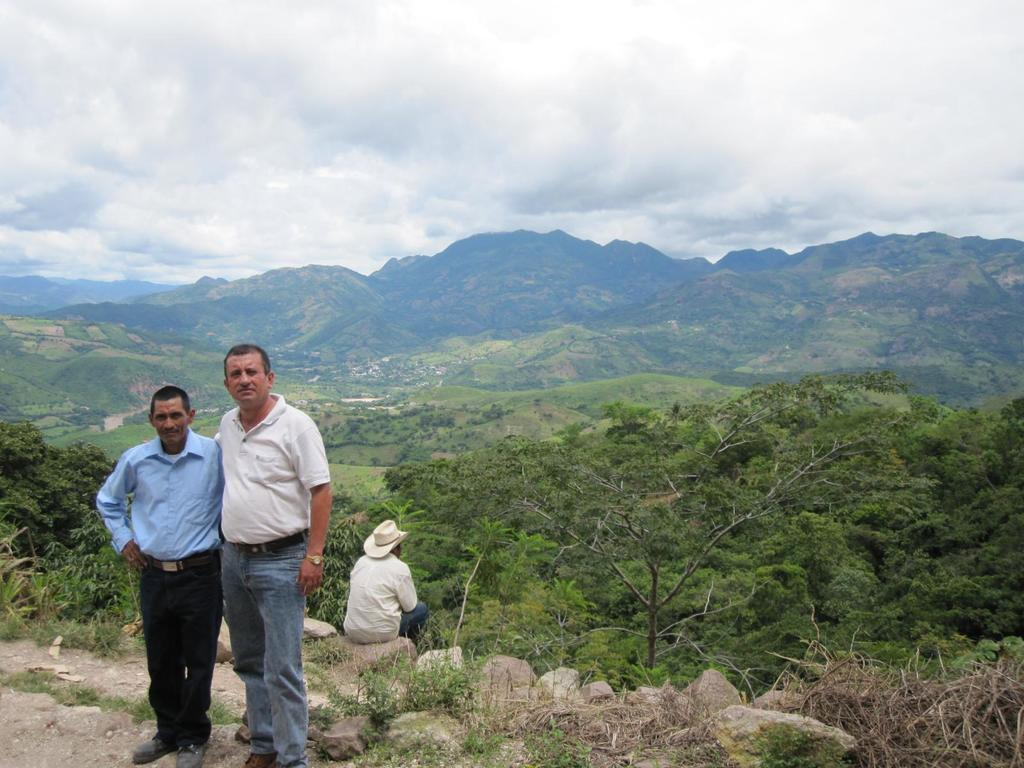How many people are in the image? There are three people in the image. What are the positions of the people in the image? Two men are standing on the ground, and one man is sitting on a rock. What type of natural environment is visible in the image? There are trees and mountains in the background, and the sky is visible in the background. What can be seen in the sky in the image? Clouds are present in the sky. What color are the toes of the man sitting on the rock? There is no information about the man's toes in the image, so we cannot determine their color. 